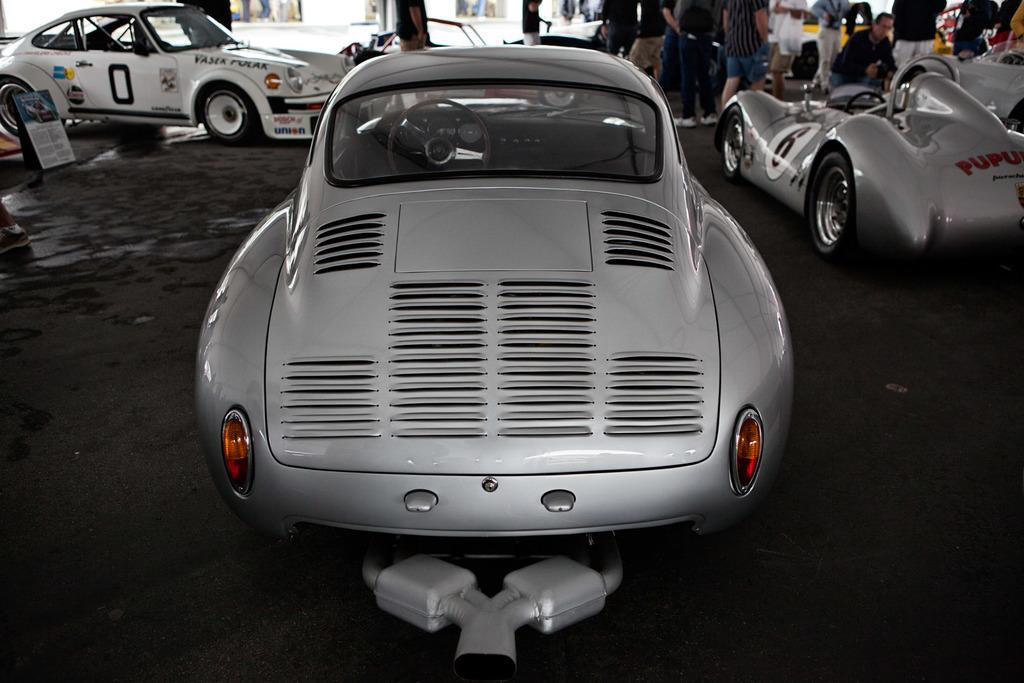What types of objects are present in the image? There are vehicles and people visible in the image. Can you describe the vehicles in the image? The vehicles are in different colors. What else can be seen in the image besides the vehicles and people? There is a board in the image. What is the weight of the town in the image? There is no town present in the image, so it is not possible to determine its weight. 